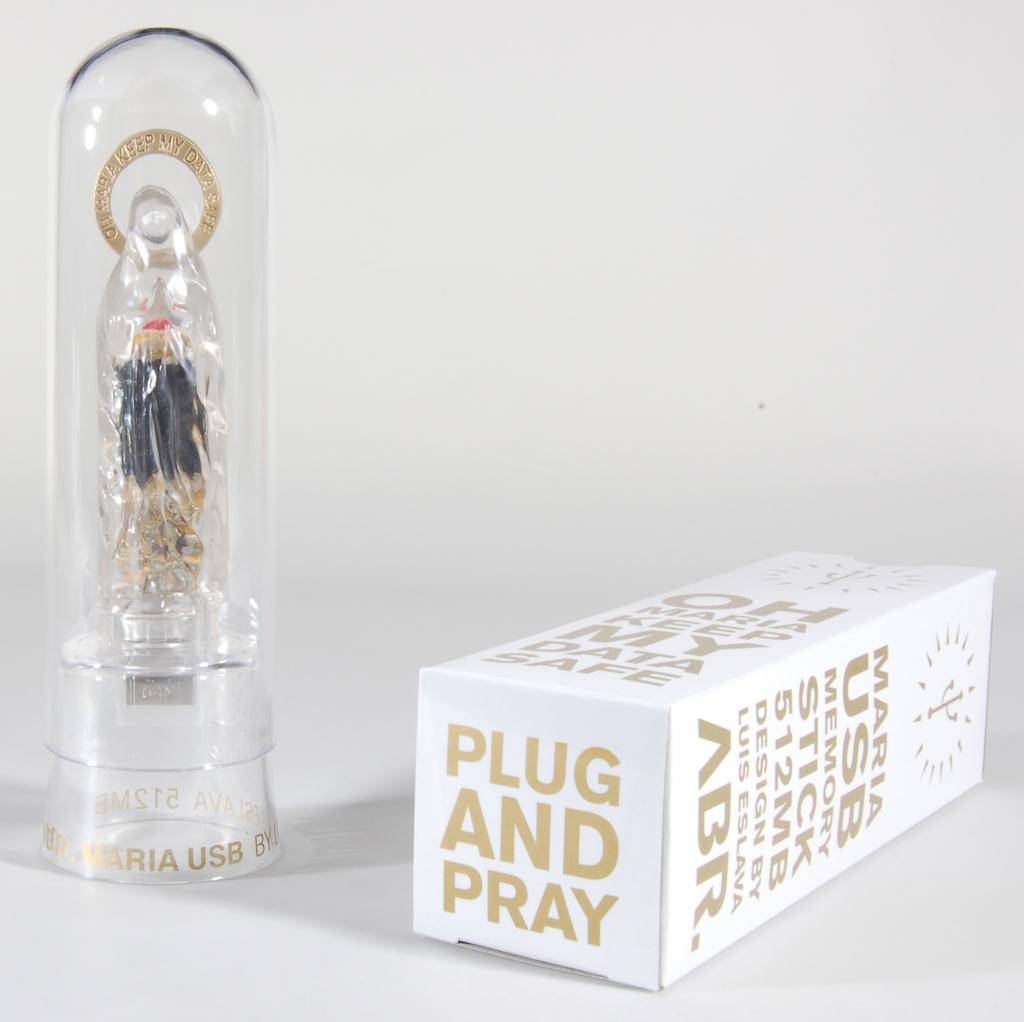<image>
Relay a brief, clear account of the picture shown. The item shown is a maria usb for a computer. 